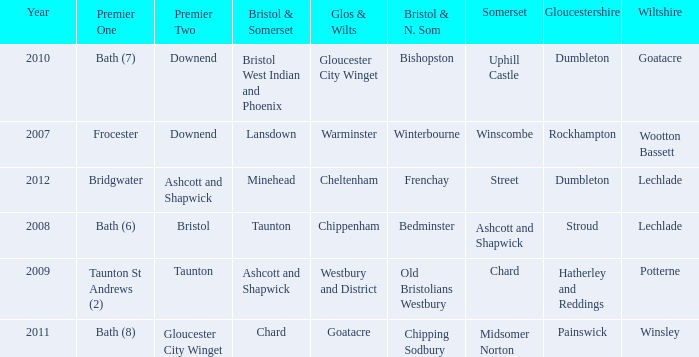What is the year where glos & wilts is gloucester city winget? 2010.0. 